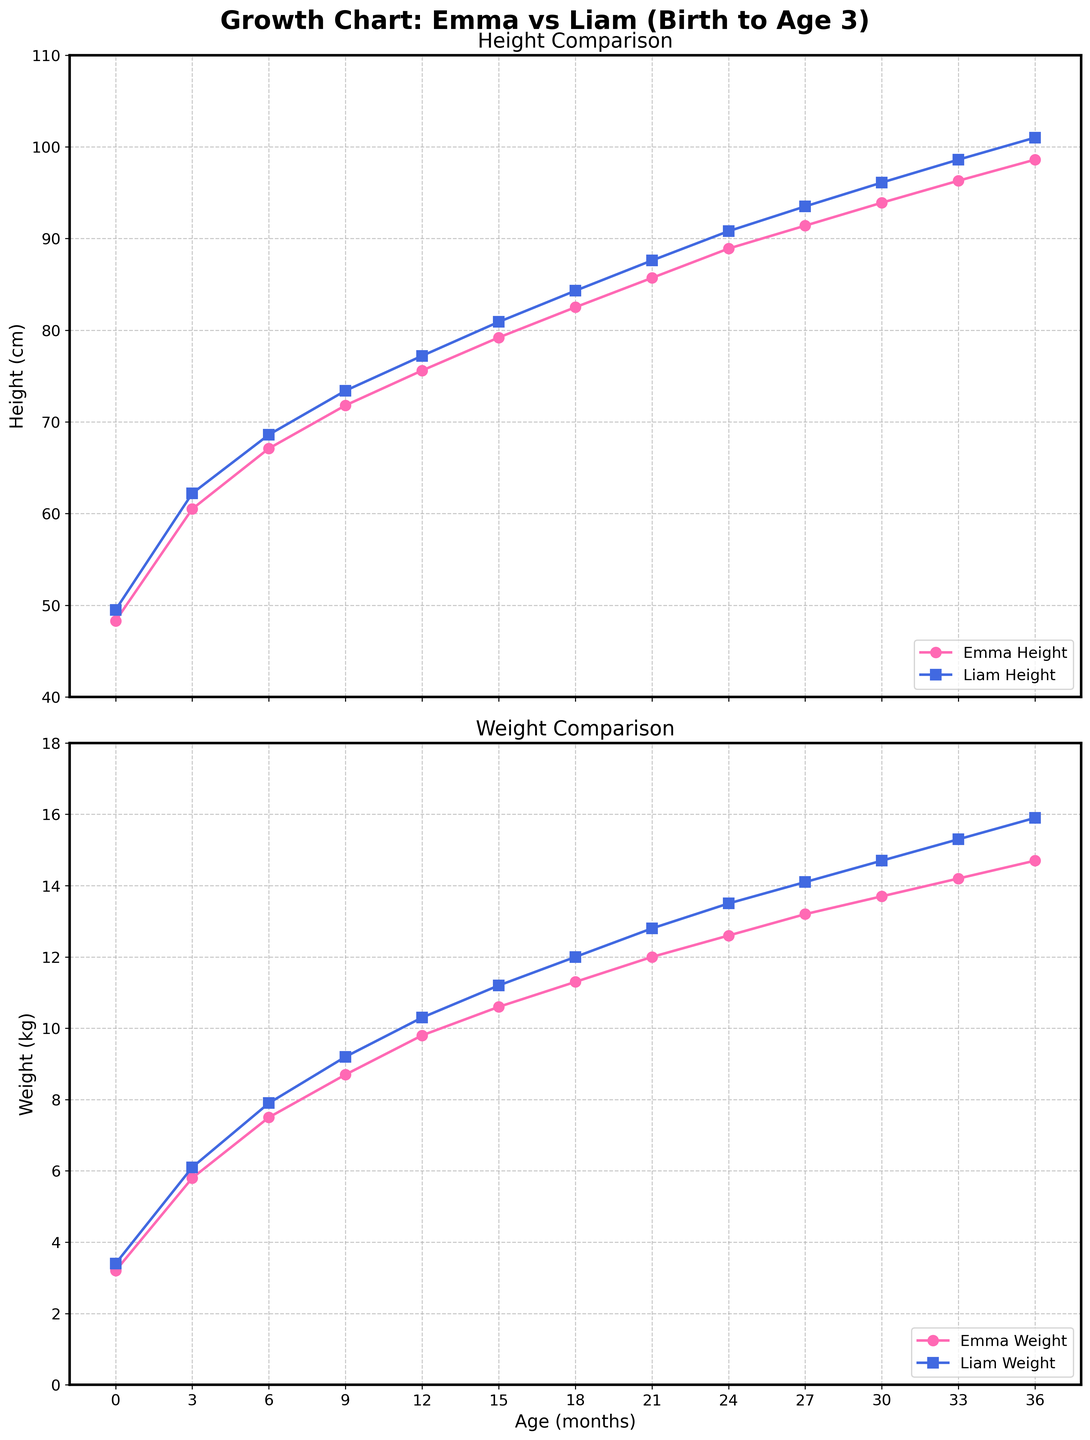Which child had a higher height at birth? Emma's height at birth is 48.3 cm, and Liam's height at birth is 49.5 cm. By comparing these two values, it is evident that Liam had a higher height at birth.
Answer: Liam At what age did Emma weigh 12 kg? Referring to Emma's weight curve in the second plot, you can see that she reached 12 kg at approximately 21 months.
Answer: 21 months How much did Liam's height increase from birth to 18 months? Liam's height at birth is 49.5 cm, and at 18 months it is 84.3 cm. The increase in height is 84.3 cm - 49.5 cm = 34.8 cm.
Answer: 34.8 cm Compare the weight of Emma and Liam at 9 months. Which one is heavier and by how much? At 9 months, Emma's weight is 8.7 kg, and Liam's weight is 9.2 kg. The difference is 9.2 kg - 8.7 kg = 0.5 kg, with Liam being heavier.
Answer: Liam by 0.5 kg Between which ages did Emma experience the smallest increase in height? By observing Emma's height curve, the smallest increase seems to occur between 21 months (85.7 cm) and 24 months (88.9 cm). The increase is 88.9 cm - 85.7 cm = 3.2 cm.
Answer: 21 to 24 months What is the average height of Emma from birth to age 3? Emma's heights are [48.3, 60.5, 67.1, 71.8, 75.6, 79.2, 82.5, 85.7, 88.9, 91.4, 93.9, 96.3, 98.6] cm. The sum is 1099.8 cm, and there are 13 data points. The average is 1099.8 / 13 ≈ 84.6 cm.
Answer: 84.6 cm Who experienced a greater weight increase from 18 to 36 months, Emma or Liam? At 18 months, Emma weighs 11.3 kg, and at 36 months, she weighs 14.7 kg. The increase is 14.7 kg - 11.3 kg = 3.4 kg. Liam weighs 12.0 kg at 18 months and 15.9 kg at 36 months, an increase of 15.9 kg - 12.0 kg = 3.9 kg. Liam had the greater increase.
Answer: Liam At what age do both Emma and Liam have the same weight? By checking the weight curves in the second plot, it appears that Emma and Liam have the same weight of around 12 kg at 21 months.
Answer: 21 months Which toddler showed more consistent growth in height, according to the graph? By visually inspecting the growth curves for height, Emma's growth shows less fluctuation and more consistent incremental increases compared to Liam's.
Answer: Emma What is the height difference between Emma and Liam at 36 months? At 36 months, Emma's height is 98.6 cm, and Liam's height is 101.0 cm. The difference is 101.0 cm - 98.6 cm = 2.4 cm.
Answer: 2.4 cm 